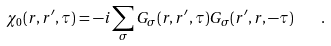Convert formula to latex. <formula><loc_0><loc_0><loc_500><loc_500>\chi _ { 0 } ( { r } , { r ^ { \prime } } , \tau ) = - i \sum _ { \sigma } G _ { \sigma } ( { r } , { r ^ { \prime } } , \tau ) G _ { \sigma } ( { r ^ { \prime } } , { r } , - \tau ) \quad .</formula> 